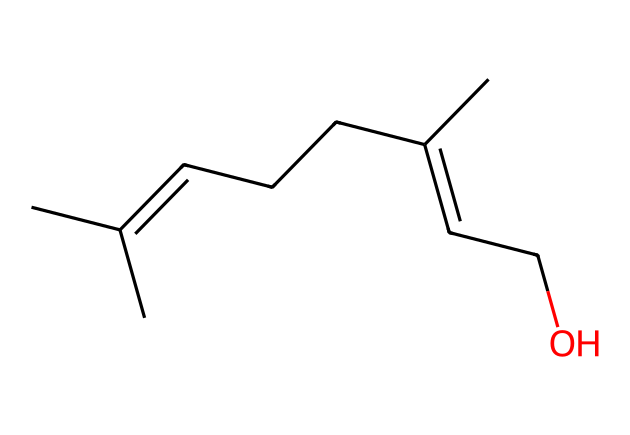What is the molecular formula of this compound? By analyzing the SMILES representation, we can count the number of carbon (C), hydrogen (H), and oxygen (O) atoms. The structure contains 10 carbon atoms, 18 hydrogen atoms, and 1 oxygen atom, leading to the molecular formula C10H18O.
Answer: C10H18O How many double bonds are present in the structure? In the given SMILES representation, we can identify whether there are any carbon-carbon double bonds. By examining the structure, we see two occurrences of the "C=C" notation. Thus, there are 2 double bonds in the compound.
Answer: 2 What type of functional group is present in this molecule? The presence of "O" in the SMILES indicates the presence of a hydroxyl group (–OH) as implied by the "CCO" at the end of the structure. This suggests that the compound contains an alcohol as its functional group.
Answer: alcohol Does this compound contain any cyclic structures? A search of the SMILES representation reveals no closed loops or rings in the structure, indicating it is a linear or branched chain molecule. Therefore, there are no cyclic groups present.
Answer: no What category of polymer does this compound belong to? Given that the structure is a simple organic molecule with a hydroxyl group and consists of repeating units or might be involved in the formation of larger polymeric materials, this compound can be classified as an alcohol-based polymer.
Answer: alcohol-based polymer How many stereocenters does this molecule have? By analyzing the structure, we can identify any carbon atoms that are attached to four different groups, which would classify them as stereocenters. Here, there are no carbon atoms meeting this criterion.
Answer: 0 